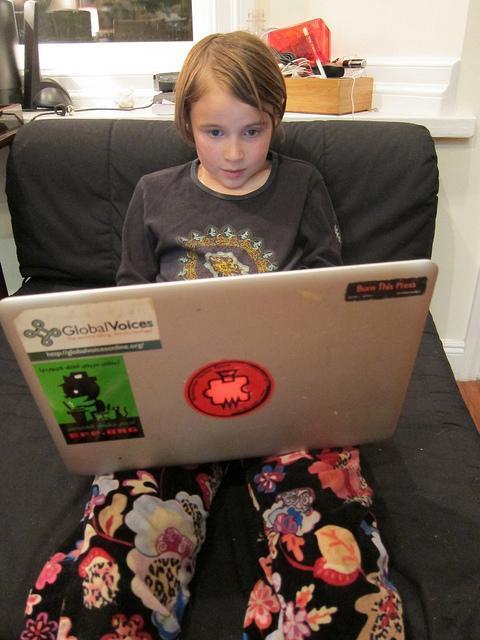Is this affirmation: "The couch is touching the person." correct?
Answer yes or no. Yes. 